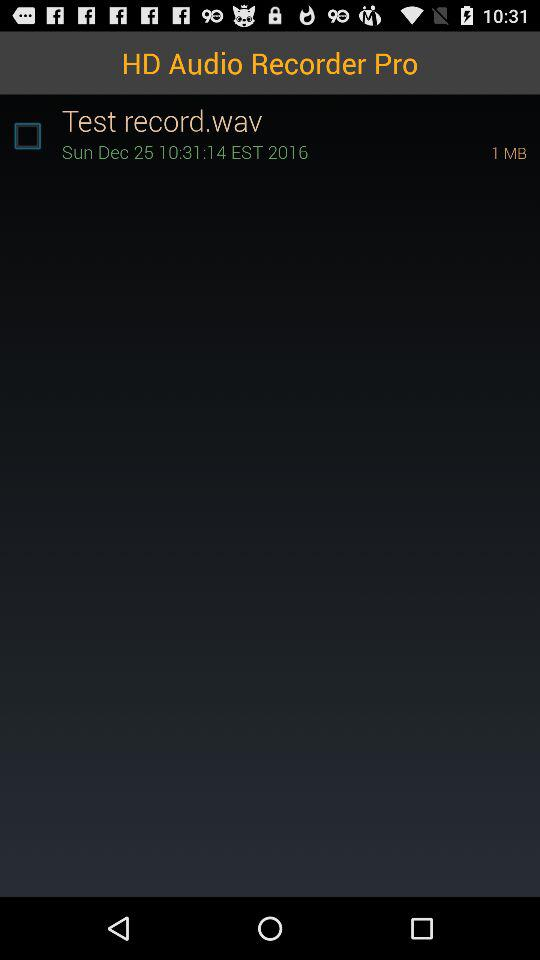What is the test recorder time? The test recorder time is 10:31:14 EST. 